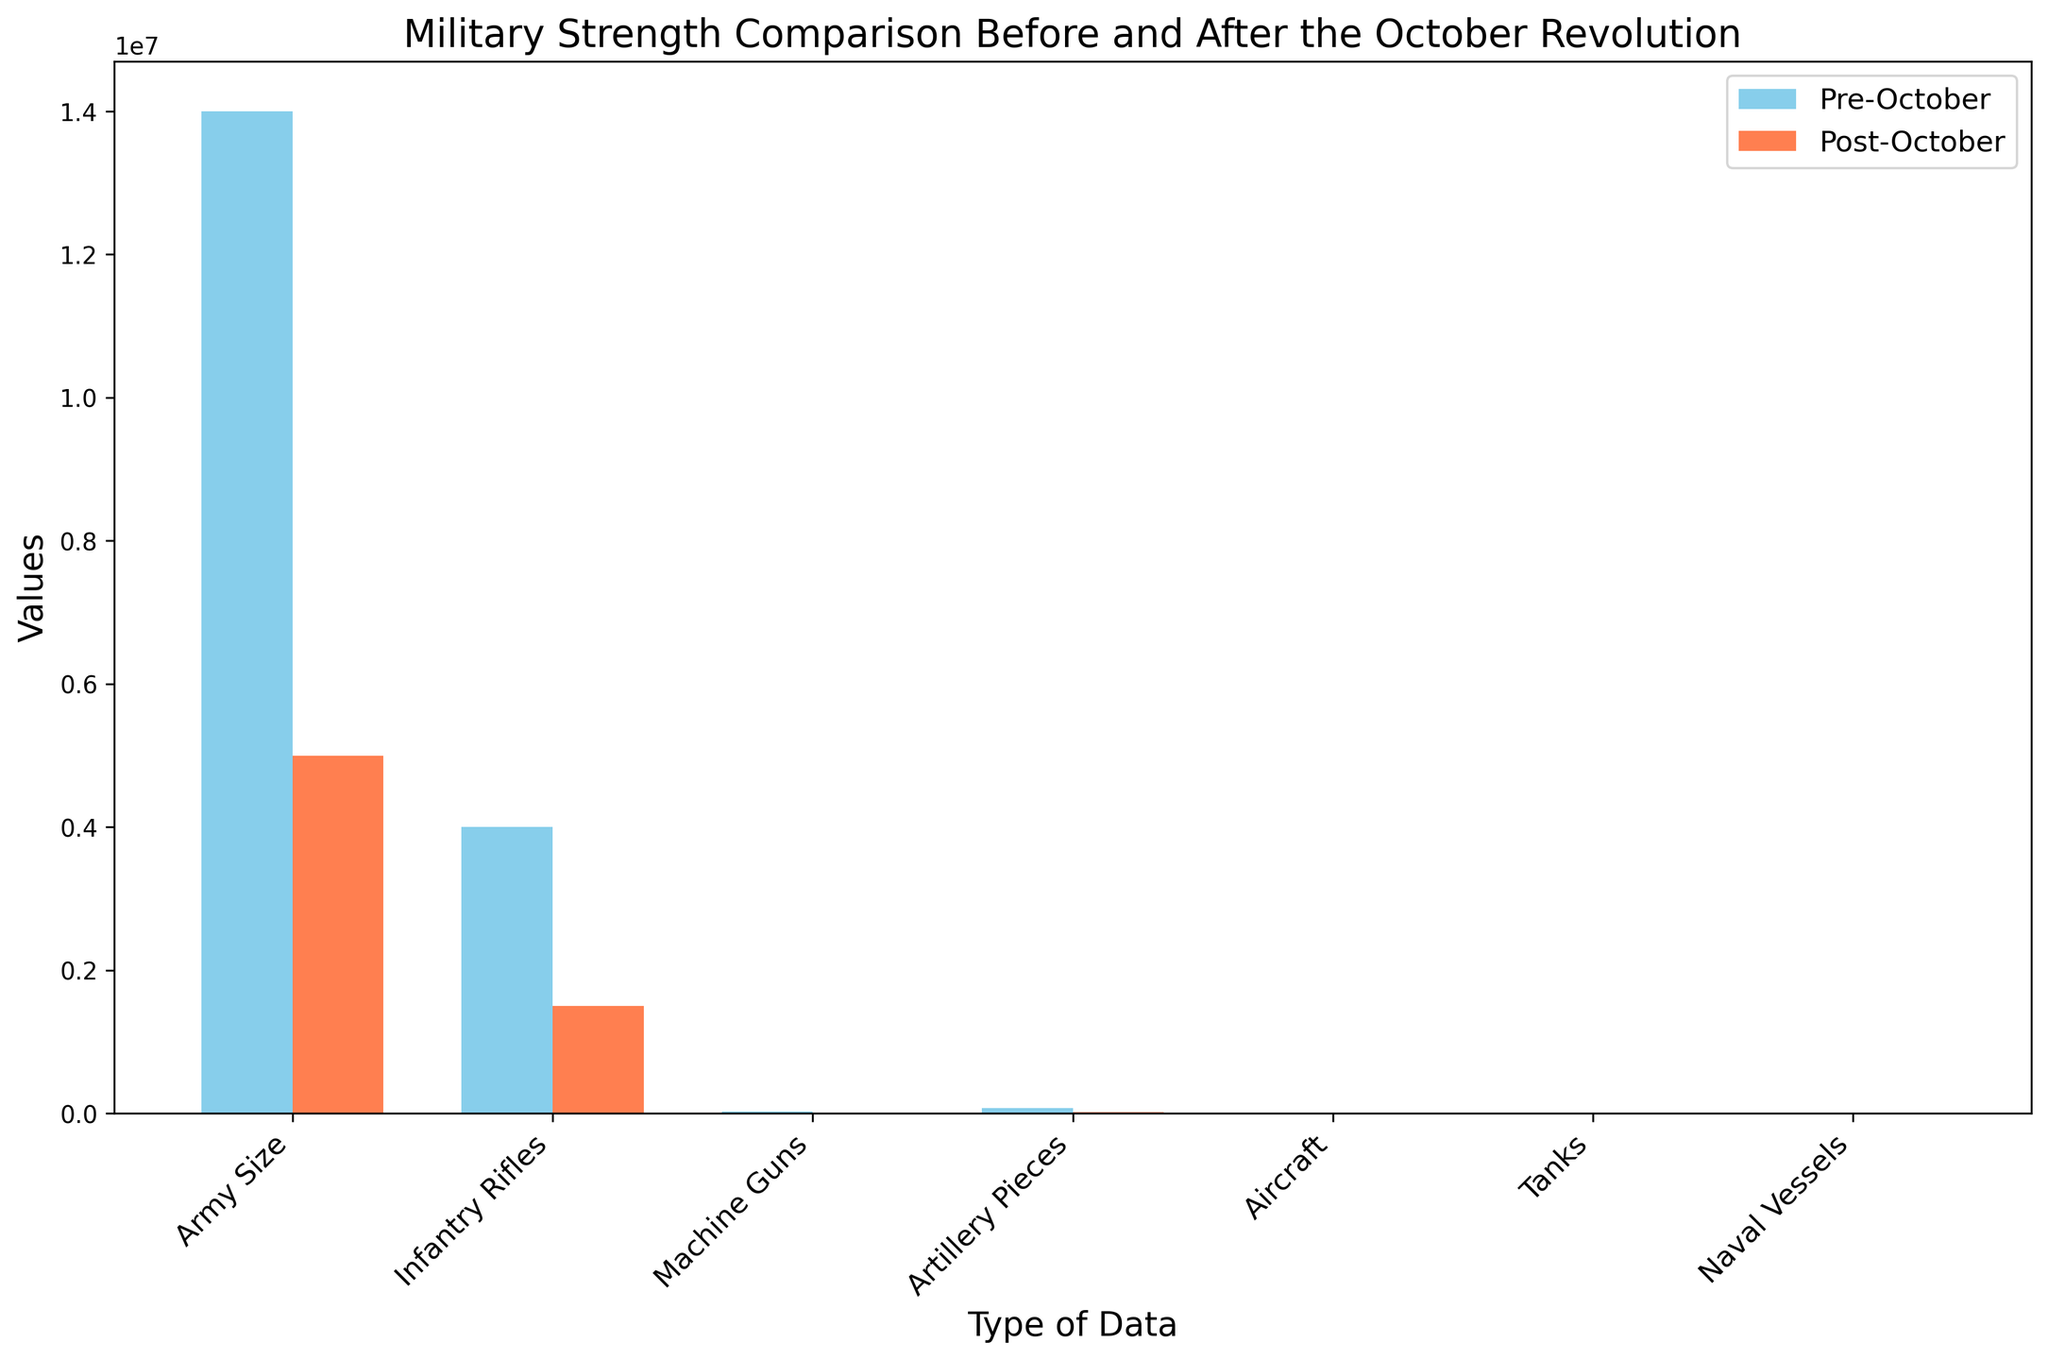What is the difference in Army Size between the pre- and post-October Revolution periods? Look at the bar heights representing the Army Size. Subtract the post-October Revolution Army Size from the pre-October Revolution Army Size: 14,000,000 - 5,000,000.
Answer: 9,000,000 Which period had more naval vessels, and by how many? Compare the heights of the bars representing Naval Vessels for both periods. Subtract the post-October number from the pre-October number: 380 - 100.
Answer: Pre-October by 280 What is the total value of Infantry Rifles and Machine Guns in the pre-October Revolution period? Add the values of Infantry Rifles and Machine Guns from the pre-October period: 4,000,000 + 26,000.
Answer: 4,026,000 Which equipment type had the smallest value in the pre-October Revolution period, and what was that value? Compare the heights of all bars in the pre-October Revolution period. The smallest value is for Tanks.
Answer: Tanks, 20 How many more artillery pieces were there in the pre-October Revolution period compared to the post-October Revolution period? Subtract the number of artillery pieces in the post-October period from those in the pre-October period: 77,000 - 20,000.
Answer: 57,000 Between aircraft and tanks, which saw a larger percentage decrease from the pre- to post-October Revolution period? Calculate the percentage decrease for both Aircraft and Tanks. For Aircraft: ((2,700 - 800) / 2,700) * 100. For Tanks: ((20 - 10) / 20) * 100. Compare the two percentages.
Answer: Aircraft, ~70.37% What is the average number of Machine Guns for the two periods combined? Add the values of Machine Guns from both periods and divide by 2: (26,000 + 8,000) / 2.
Answer: 17,000 Which type of data had an equal or nearly equal value in both periods? Compare the bar heights for all types of data across both periods. Tanks have the closest values: 20 pre-October, and 10 post-October.
Answer: Tanks How much did the value of Infantry Rifles decrease from the pre- to post-October Revolution? Subtract the post-October value from the pre-October value for Infantry Rifles: 4,000,000 - 1,500,000.
Answer: 2,500,000 What is the total count of all equipment types excluding Army Size in the post-October period? Sum the values of all equipment types excluding Army Size for the post-October period: 1,500,000 (Infantry Rifles) + 8,000 (Machine Guns) + 20,000 (Artillery Pieces) + 800 (Aircraft) + 10 (Tanks) + 100 (Naval Vessels).
Answer: 1,528,910 